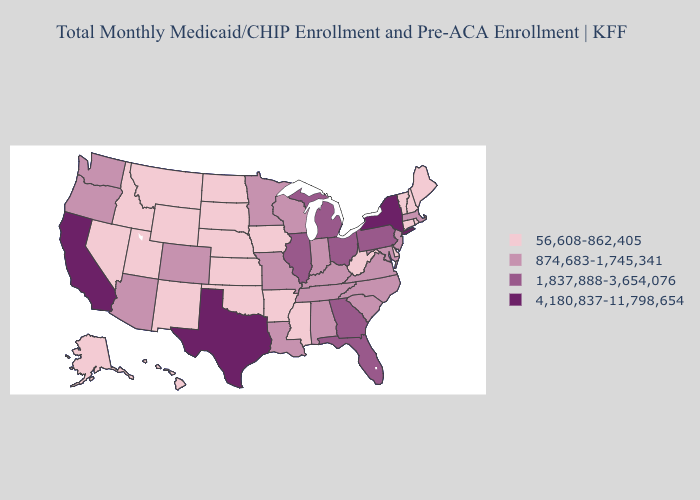Which states have the lowest value in the Northeast?
Short answer required. Connecticut, Maine, New Hampshire, Rhode Island, Vermont. Does Washington have the lowest value in the USA?
Short answer required. No. Among the states that border Georgia , does South Carolina have the highest value?
Answer briefly. No. What is the value of Oregon?
Give a very brief answer. 874,683-1,745,341. Does Michigan have a higher value than Illinois?
Keep it brief. No. Which states have the highest value in the USA?
Keep it brief. California, New York, Texas. Name the states that have a value in the range 56,608-862,405?
Short answer required. Alaska, Arkansas, Connecticut, Delaware, Hawaii, Idaho, Iowa, Kansas, Maine, Mississippi, Montana, Nebraska, Nevada, New Hampshire, New Mexico, North Dakota, Oklahoma, Rhode Island, South Dakota, Utah, Vermont, West Virginia, Wyoming. Which states hav the highest value in the Northeast?
Keep it brief. New York. Does Nevada have the same value as New Mexico?
Write a very short answer. Yes. Which states have the lowest value in the USA?
Answer briefly. Alaska, Arkansas, Connecticut, Delaware, Hawaii, Idaho, Iowa, Kansas, Maine, Mississippi, Montana, Nebraska, Nevada, New Hampshire, New Mexico, North Dakota, Oklahoma, Rhode Island, South Dakota, Utah, Vermont, West Virginia, Wyoming. What is the value of New Mexico?
Quick response, please. 56,608-862,405. Among the states that border Nebraska , does Missouri have the highest value?
Quick response, please. Yes. What is the lowest value in states that border Colorado?
Answer briefly. 56,608-862,405. Name the states that have a value in the range 1,837,888-3,654,076?
Keep it brief. Florida, Georgia, Illinois, Michigan, Ohio, Pennsylvania. What is the value of Michigan?
Give a very brief answer. 1,837,888-3,654,076. 